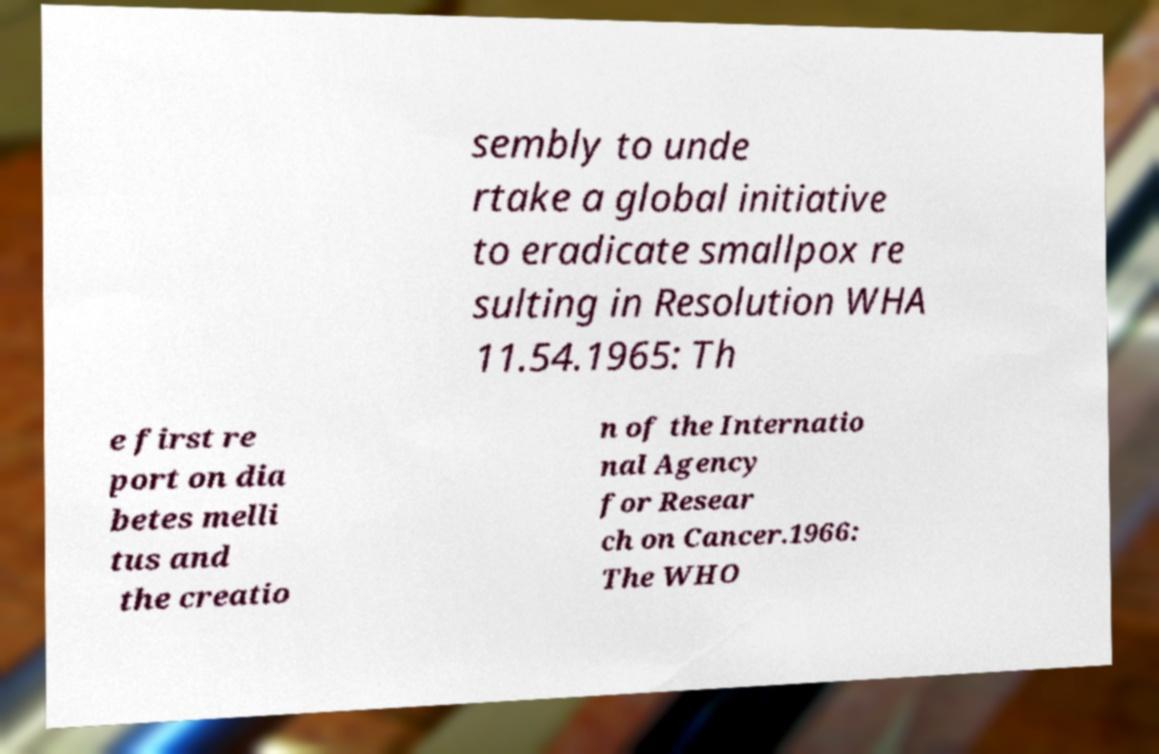Can you accurately transcribe the text from the provided image for me? sembly to unde rtake a global initiative to eradicate smallpox re sulting in Resolution WHA 11.54.1965: Th e first re port on dia betes melli tus and the creatio n of the Internatio nal Agency for Resear ch on Cancer.1966: The WHO 